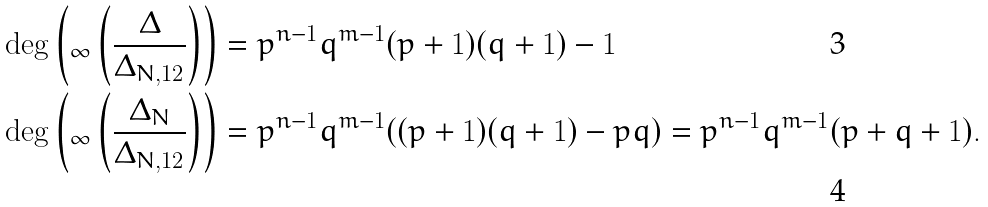Convert formula to latex. <formula><loc_0><loc_0><loc_500><loc_500>& \deg \left ( _ { \infty } \left ( \frac { \Delta } { \Delta _ { N , 1 2 } } \right ) \right ) = p ^ { n - 1 } q ^ { m - 1 } ( p + 1 ) ( q + 1 ) - 1 \\ & \deg \left ( _ { \infty } \left ( \frac { \Delta _ { N } } { \Delta _ { N , 1 2 } } \right ) \right ) = p ^ { n - 1 } q ^ { m - 1 } ( ( p + 1 ) ( q + 1 ) - p q ) = p ^ { n - 1 } q ^ { m - 1 } ( p + q + 1 ) .</formula> 